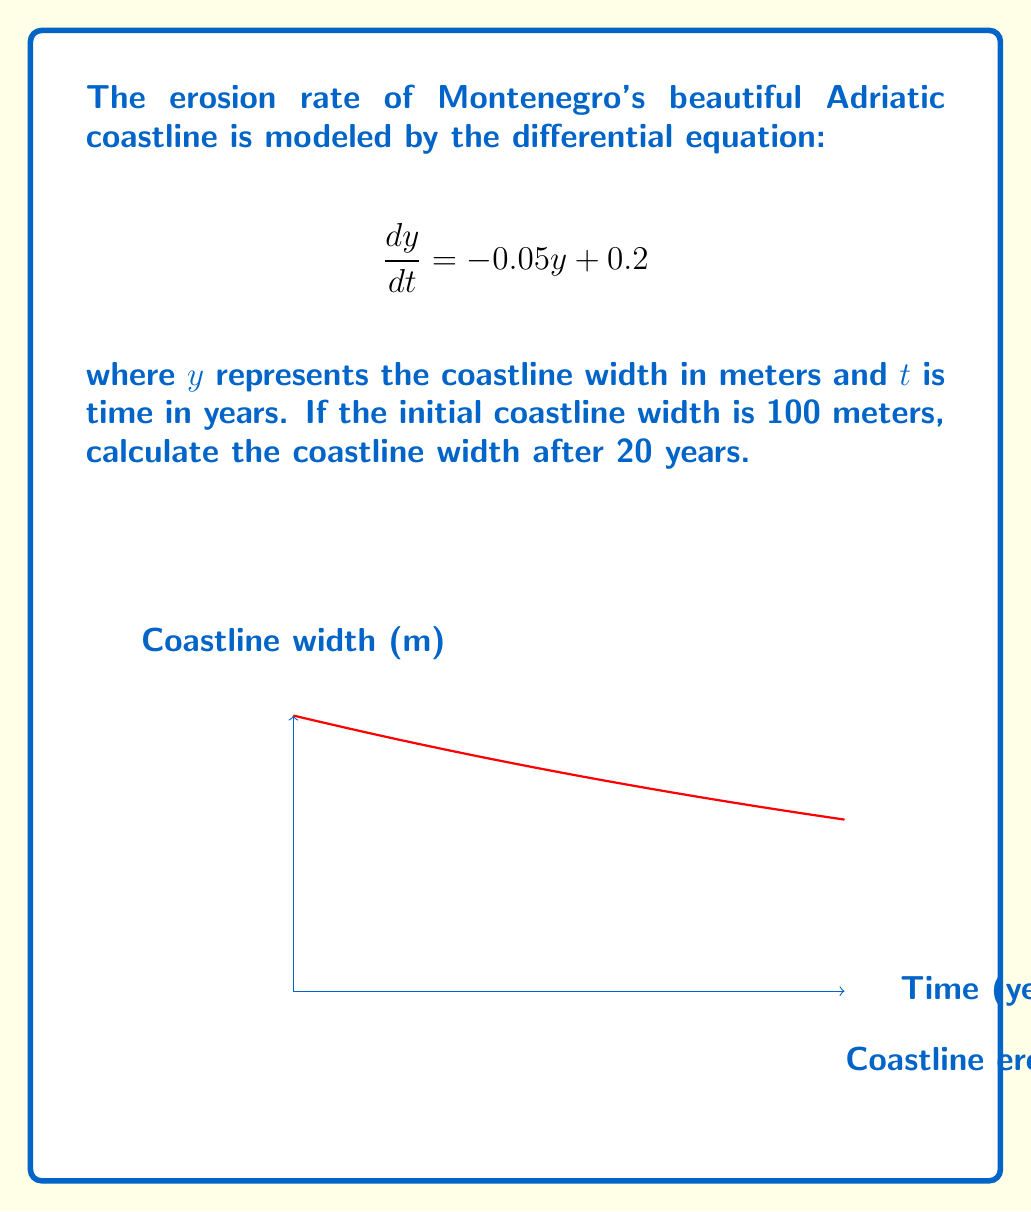Give your solution to this math problem. Let's solve this problem step by step:

1) The given differential equation is a linear first-order equation:
   $$\frac{dy}{dt} = -0.05y + 0.2$$

2) The general solution for this type of equation is:
   $$y = Ce^{-0.05t} + 4$$
   where $C$ is a constant to be determined from the initial condition.

3) We're given that the initial coastline width is 100 meters. So at $t=0$, $y=100$:
   $$100 = Ce^{-0.05(0)} + 4$$
   $$100 = C + 4$$
   $$C = 96$$

4) Substituting this back into our general solution:
   $$y = 96e^{-0.05t} + 4$$

5) To find the coastline width after 20 years, we substitute $t=20$:
   $$y = 96e^{-0.05(20)} + 4$$
   $$y = 96e^{-1} + 4$$
   $$y \approx 39.32$$

Therefore, after 20 years, the coastline width will be approximately 39.32 meters.
Answer: 39.32 meters 